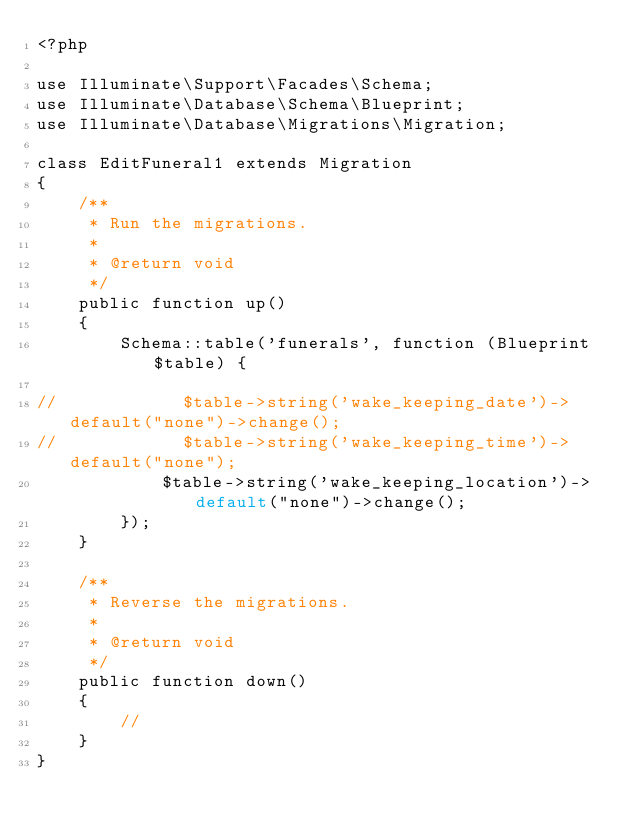<code> <loc_0><loc_0><loc_500><loc_500><_PHP_><?php

use Illuminate\Support\Facades\Schema;
use Illuminate\Database\Schema\Blueprint;
use Illuminate\Database\Migrations\Migration;

class EditFuneral1 extends Migration
{
    /**
     * Run the migrations.
     *
     * @return void
     */
    public function up()
    {
        Schema::table('funerals', function (Blueprint $table) {

//            $table->string('wake_keeping_date')->default("none")->change();
//            $table->string('wake_keeping_time')->default("none");
            $table->string('wake_keeping_location')->default("none")->change();
        });
    }

    /**
     * Reverse the migrations.
     *
     * @return void
     */
    public function down()
    {
        //
    }
}
</code> 